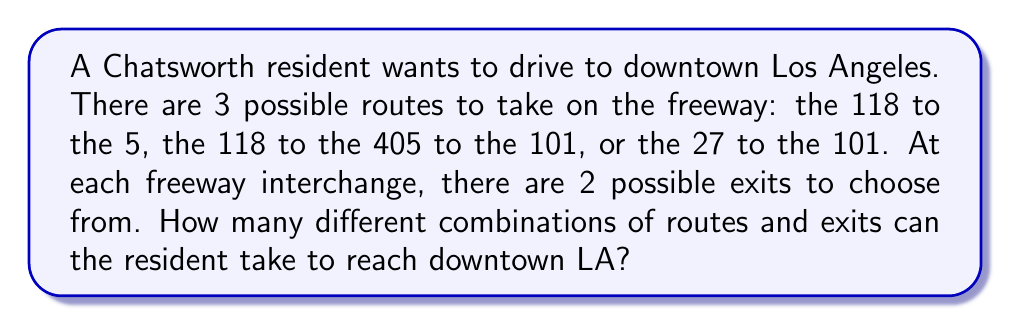Provide a solution to this math problem. Let's break this down step-by-step:

1) First, we need to consider the number of main route choices:
   There are 3 possible routes: 118-5, 118-405-101, and 27-101

2) Now, let's consider the number of exit choices for each route:

   a) 118-5 route:
      - 1 interchange (where 118 meets 5)
      - 2 possible exits at this interchange
      Total combinations for this route: $2^1 = 2$

   b) 118-405-101 route:
      - 2 interchanges (118-405 and 405-101)
      - 2 possible exits at each interchange
      Total combinations for this route: $2^2 = 4$

   c) 27-101 route:
      - 1 interchange (where 27 meets 101)
      - 2 possible exits at this interchange
      Total combinations for this route: $2^1 = 2$

3) To find the total number of combinations, we sum the combinations for each route:

   Total combinations = 2 + 4 + 2 = 8

Therefore, there are 8 different combinations of routes and exits the resident can take.
Answer: 8 combinations 